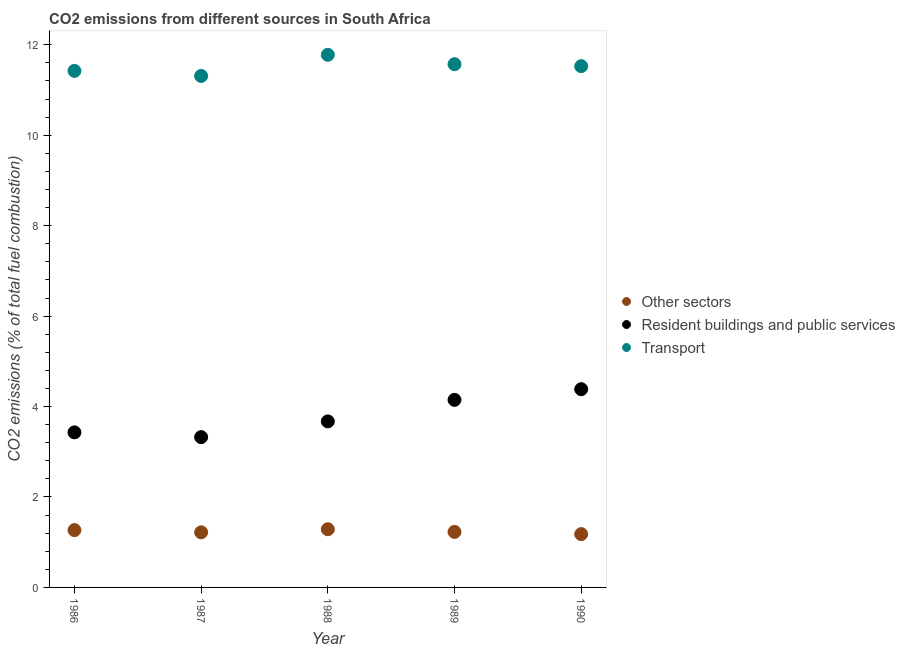What is the percentage of co2 emissions from transport in 1986?
Provide a short and direct response. 11.42. Across all years, what is the maximum percentage of co2 emissions from resident buildings and public services?
Provide a short and direct response. 4.38. Across all years, what is the minimum percentage of co2 emissions from resident buildings and public services?
Ensure brevity in your answer.  3.32. What is the total percentage of co2 emissions from transport in the graph?
Provide a short and direct response. 57.61. What is the difference between the percentage of co2 emissions from transport in 1986 and that in 1988?
Your response must be concise. -0.36. What is the difference between the percentage of co2 emissions from resident buildings and public services in 1988 and the percentage of co2 emissions from transport in 1990?
Keep it short and to the point. -7.86. What is the average percentage of co2 emissions from resident buildings and public services per year?
Provide a succinct answer. 3.79. In the year 1988, what is the difference between the percentage of co2 emissions from resident buildings and public services and percentage of co2 emissions from transport?
Your answer should be compact. -8.11. What is the ratio of the percentage of co2 emissions from transport in 1989 to that in 1990?
Keep it short and to the point. 1. Is the difference between the percentage of co2 emissions from transport in 1987 and 1988 greater than the difference between the percentage of co2 emissions from other sectors in 1987 and 1988?
Ensure brevity in your answer.  No. What is the difference between the highest and the second highest percentage of co2 emissions from transport?
Make the answer very short. 0.21. What is the difference between the highest and the lowest percentage of co2 emissions from transport?
Offer a terse response. 0.47. In how many years, is the percentage of co2 emissions from resident buildings and public services greater than the average percentage of co2 emissions from resident buildings and public services taken over all years?
Make the answer very short. 2. Is the sum of the percentage of co2 emissions from transport in 1988 and 1990 greater than the maximum percentage of co2 emissions from resident buildings and public services across all years?
Your answer should be compact. Yes. Does the percentage of co2 emissions from transport monotonically increase over the years?
Ensure brevity in your answer.  No. How many dotlines are there?
Provide a short and direct response. 3. Does the graph contain grids?
Offer a terse response. No. Where does the legend appear in the graph?
Your answer should be very brief. Center right. How are the legend labels stacked?
Offer a very short reply. Vertical. What is the title of the graph?
Offer a very short reply. CO2 emissions from different sources in South Africa. Does "Total employers" appear as one of the legend labels in the graph?
Your answer should be compact. No. What is the label or title of the Y-axis?
Offer a very short reply. CO2 emissions (% of total fuel combustion). What is the CO2 emissions (% of total fuel combustion) of Other sectors in 1986?
Offer a terse response. 1.27. What is the CO2 emissions (% of total fuel combustion) in Resident buildings and public services in 1986?
Keep it short and to the point. 3.43. What is the CO2 emissions (% of total fuel combustion) of Transport in 1986?
Your answer should be very brief. 11.42. What is the CO2 emissions (% of total fuel combustion) in Other sectors in 1987?
Your answer should be compact. 1.22. What is the CO2 emissions (% of total fuel combustion) in Resident buildings and public services in 1987?
Your answer should be compact. 3.32. What is the CO2 emissions (% of total fuel combustion) of Transport in 1987?
Provide a short and direct response. 11.31. What is the CO2 emissions (% of total fuel combustion) of Other sectors in 1988?
Give a very brief answer. 1.29. What is the CO2 emissions (% of total fuel combustion) of Resident buildings and public services in 1988?
Your response must be concise. 3.67. What is the CO2 emissions (% of total fuel combustion) of Transport in 1988?
Offer a terse response. 11.78. What is the CO2 emissions (% of total fuel combustion) in Other sectors in 1989?
Your answer should be compact. 1.23. What is the CO2 emissions (% of total fuel combustion) of Resident buildings and public services in 1989?
Your answer should be very brief. 4.15. What is the CO2 emissions (% of total fuel combustion) in Transport in 1989?
Offer a very short reply. 11.57. What is the CO2 emissions (% of total fuel combustion) of Other sectors in 1990?
Keep it short and to the point. 1.18. What is the CO2 emissions (% of total fuel combustion) in Resident buildings and public services in 1990?
Your answer should be compact. 4.38. What is the CO2 emissions (% of total fuel combustion) of Transport in 1990?
Keep it short and to the point. 11.53. Across all years, what is the maximum CO2 emissions (% of total fuel combustion) of Other sectors?
Your answer should be very brief. 1.29. Across all years, what is the maximum CO2 emissions (% of total fuel combustion) in Resident buildings and public services?
Provide a succinct answer. 4.38. Across all years, what is the maximum CO2 emissions (% of total fuel combustion) in Transport?
Your response must be concise. 11.78. Across all years, what is the minimum CO2 emissions (% of total fuel combustion) in Other sectors?
Ensure brevity in your answer.  1.18. Across all years, what is the minimum CO2 emissions (% of total fuel combustion) in Resident buildings and public services?
Offer a very short reply. 3.32. Across all years, what is the minimum CO2 emissions (% of total fuel combustion) of Transport?
Provide a succinct answer. 11.31. What is the total CO2 emissions (% of total fuel combustion) of Other sectors in the graph?
Make the answer very short. 6.18. What is the total CO2 emissions (% of total fuel combustion) in Resident buildings and public services in the graph?
Ensure brevity in your answer.  18.96. What is the total CO2 emissions (% of total fuel combustion) in Transport in the graph?
Provide a succinct answer. 57.61. What is the difference between the CO2 emissions (% of total fuel combustion) in Other sectors in 1986 and that in 1987?
Make the answer very short. 0.05. What is the difference between the CO2 emissions (% of total fuel combustion) in Resident buildings and public services in 1986 and that in 1987?
Your answer should be very brief. 0.11. What is the difference between the CO2 emissions (% of total fuel combustion) in Transport in 1986 and that in 1987?
Offer a very short reply. 0.11. What is the difference between the CO2 emissions (% of total fuel combustion) in Other sectors in 1986 and that in 1988?
Offer a very short reply. -0.02. What is the difference between the CO2 emissions (% of total fuel combustion) in Resident buildings and public services in 1986 and that in 1988?
Offer a very short reply. -0.24. What is the difference between the CO2 emissions (% of total fuel combustion) in Transport in 1986 and that in 1988?
Your response must be concise. -0.36. What is the difference between the CO2 emissions (% of total fuel combustion) of Other sectors in 1986 and that in 1989?
Provide a short and direct response. 0.04. What is the difference between the CO2 emissions (% of total fuel combustion) of Resident buildings and public services in 1986 and that in 1989?
Ensure brevity in your answer.  -0.72. What is the difference between the CO2 emissions (% of total fuel combustion) of Transport in 1986 and that in 1989?
Provide a short and direct response. -0.15. What is the difference between the CO2 emissions (% of total fuel combustion) of Other sectors in 1986 and that in 1990?
Your answer should be very brief. 0.09. What is the difference between the CO2 emissions (% of total fuel combustion) of Resident buildings and public services in 1986 and that in 1990?
Your answer should be compact. -0.95. What is the difference between the CO2 emissions (% of total fuel combustion) in Transport in 1986 and that in 1990?
Offer a terse response. -0.1. What is the difference between the CO2 emissions (% of total fuel combustion) of Other sectors in 1987 and that in 1988?
Keep it short and to the point. -0.07. What is the difference between the CO2 emissions (% of total fuel combustion) of Resident buildings and public services in 1987 and that in 1988?
Offer a terse response. -0.35. What is the difference between the CO2 emissions (% of total fuel combustion) of Transport in 1987 and that in 1988?
Provide a short and direct response. -0.47. What is the difference between the CO2 emissions (% of total fuel combustion) in Other sectors in 1987 and that in 1989?
Your response must be concise. -0.01. What is the difference between the CO2 emissions (% of total fuel combustion) in Resident buildings and public services in 1987 and that in 1989?
Your response must be concise. -0.82. What is the difference between the CO2 emissions (% of total fuel combustion) of Transport in 1987 and that in 1989?
Offer a very short reply. -0.26. What is the difference between the CO2 emissions (% of total fuel combustion) in Other sectors in 1987 and that in 1990?
Make the answer very short. 0.04. What is the difference between the CO2 emissions (% of total fuel combustion) of Resident buildings and public services in 1987 and that in 1990?
Keep it short and to the point. -1.06. What is the difference between the CO2 emissions (% of total fuel combustion) in Transport in 1987 and that in 1990?
Keep it short and to the point. -0.22. What is the difference between the CO2 emissions (% of total fuel combustion) of Other sectors in 1988 and that in 1989?
Give a very brief answer. 0.06. What is the difference between the CO2 emissions (% of total fuel combustion) in Resident buildings and public services in 1988 and that in 1989?
Offer a terse response. -0.48. What is the difference between the CO2 emissions (% of total fuel combustion) of Transport in 1988 and that in 1989?
Give a very brief answer. 0.21. What is the difference between the CO2 emissions (% of total fuel combustion) in Other sectors in 1988 and that in 1990?
Offer a very short reply. 0.11. What is the difference between the CO2 emissions (% of total fuel combustion) of Resident buildings and public services in 1988 and that in 1990?
Offer a terse response. -0.71. What is the difference between the CO2 emissions (% of total fuel combustion) in Transport in 1988 and that in 1990?
Your answer should be very brief. 0.25. What is the difference between the CO2 emissions (% of total fuel combustion) in Other sectors in 1989 and that in 1990?
Provide a succinct answer. 0.05. What is the difference between the CO2 emissions (% of total fuel combustion) of Resident buildings and public services in 1989 and that in 1990?
Offer a terse response. -0.24. What is the difference between the CO2 emissions (% of total fuel combustion) of Transport in 1989 and that in 1990?
Your answer should be very brief. 0.04. What is the difference between the CO2 emissions (% of total fuel combustion) in Other sectors in 1986 and the CO2 emissions (% of total fuel combustion) in Resident buildings and public services in 1987?
Your answer should be very brief. -2.06. What is the difference between the CO2 emissions (% of total fuel combustion) in Other sectors in 1986 and the CO2 emissions (% of total fuel combustion) in Transport in 1987?
Offer a terse response. -10.04. What is the difference between the CO2 emissions (% of total fuel combustion) in Resident buildings and public services in 1986 and the CO2 emissions (% of total fuel combustion) in Transport in 1987?
Ensure brevity in your answer.  -7.88. What is the difference between the CO2 emissions (% of total fuel combustion) in Other sectors in 1986 and the CO2 emissions (% of total fuel combustion) in Resident buildings and public services in 1988?
Give a very brief answer. -2.4. What is the difference between the CO2 emissions (% of total fuel combustion) in Other sectors in 1986 and the CO2 emissions (% of total fuel combustion) in Transport in 1988?
Ensure brevity in your answer.  -10.51. What is the difference between the CO2 emissions (% of total fuel combustion) in Resident buildings and public services in 1986 and the CO2 emissions (% of total fuel combustion) in Transport in 1988?
Your answer should be very brief. -8.35. What is the difference between the CO2 emissions (% of total fuel combustion) of Other sectors in 1986 and the CO2 emissions (% of total fuel combustion) of Resident buildings and public services in 1989?
Ensure brevity in your answer.  -2.88. What is the difference between the CO2 emissions (% of total fuel combustion) of Other sectors in 1986 and the CO2 emissions (% of total fuel combustion) of Transport in 1989?
Your answer should be very brief. -10.3. What is the difference between the CO2 emissions (% of total fuel combustion) in Resident buildings and public services in 1986 and the CO2 emissions (% of total fuel combustion) in Transport in 1989?
Provide a short and direct response. -8.14. What is the difference between the CO2 emissions (% of total fuel combustion) in Other sectors in 1986 and the CO2 emissions (% of total fuel combustion) in Resident buildings and public services in 1990?
Your answer should be compact. -3.12. What is the difference between the CO2 emissions (% of total fuel combustion) in Other sectors in 1986 and the CO2 emissions (% of total fuel combustion) in Transport in 1990?
Provide a succinct answer. -10.26. What is the difference between the CO2 emissions (% of total fuel combustion) in Resident buildings and public services in 1986 and the CO2 emissions (% of total fuel combustion) in Transport in 1990?
Offer a very short reply. -8.1. What is the difference between the CO2 emissions (% of total fuel combustion) of Other sectors in 1987 and the CO2 emissions (% of total fuel combustion) of Resident buildings and public services in 1988?
Provide a succinct answer. -2.45. What is the difference between the CO2 emissions (% of total fuel combustion) of Other sectors in 1987 and the CO2 emissions (% of total fuel combustion) of Transport in 1988?
Make the answer very short. -10.56. What is the difference between the CO2 emissions (% of total fuel combustion) of Resident buildings and public services in 1987 and the CO2 emissions (% of total fuel combustion) of Transport in 1988?
Provide a short and direct response. -8.46. What is the difference between the CO2 emissions (% of total fuel combustion) in Other sectors in 1987 and the CO2 emissions (% of total fuel combustion) in Resident buildings and public services in 1989?
Provide a succinct answer. -2.93. What is the difference between the CO2 emissions (% of total fuel combustion) in Other sectors in 1987 and the CO2 emissions (% of total fuel combustion) in Transport in 1989?
Offer a terse response. -10.35. What is the difference between the CO2 emissions (% of total fuel combustion) of Resident buildings and public services in 1987 and the CO2 emissions (% of total fuel combustion) of Transport in 1989?
Provide a succinct answer. -8.25. What is the difference between the CO2 emissions (% of total fuel combustion) of Other sectors in 1987 and the CO2 emissions (% of total fuel combustion) of Resident buildings and public services in 1990?
Your response must be concise. -3.17. What is the difference between the CO2 emissions (% of total fuel combustion) in Other sectors in 1987 and the CO2 emissions (% of total fuel combustion) in Transport in 1990?
Your response must be concise. -10.31. What is the difference between the CO2 emissions (% of total fuel combustion) in Resident buildings and public services in 1987 and the CO2 emissions (% of total fuel combustion) in Transport in 1990?
Keep it short and to the point. -8.2. What is the difference between the CO2 emissions (% of total fuel combustion) of Other sectors in 1988 and the CO2 emissions (% of total fuel combustion) of Resident buildings and public services in 1989?
Your answer should be very brief. -2.86. What is the difference between the CO2 emissions (% of total fuel combustion) of Other sectors in 1988 and the CO2 emissions (% of total fuel combustion) of Transport in 1989?
Your answer should be compact. -10.28. What is the difference between the CO2 emissions (% of total fuel combustion) of Resident buildings and public services in 1988 and the CO2 emissions (% of total fuel combustion) of Transport in 1989?
Your answer should be very brief. -7.9. What is the difference between the CO2 emissions (% of total fuel combustion) of Other sectors in 1988 and the CO2 emissions (% of total fuel combustion) of Resident buildings and public services in 1990?
Your answer should be very brief. -3.1. What is the difference between the CO2 emissions (% of total fuel combustion) in Other sectors in 1988 and the CO2 emissions (% of total fuel combustion) in Transport in 1990?
Provide a succinct answer. -10.24. What is the difference between the CO2 emissions (% of total fuel combustion) in Resident buildings and public services in 1988 and the CO2 emissions (% of total fuel combustion) in Transport in 1990?
Ensure brevity in your answer.  -7.86. What is the difference between the CO2 emissions (% of total fuel combustion) of Other sectors in 1989 and the CO2 emissions (% of total fuel combustion) of Resident buildings and public services in 1990?
Make the answer very short. -3.16. What is the difference between the CO2 emissions (% of total fuel combustion) in Other sectors in 1989 and the CO2 emissions (% of total fuel combustion) in Transport in 1990?
Ensure brevity in your answer.  -10.3. What is the difference between the CO2 emissions (% of total fuel combustion) in Resident buildings and public services in 1989 and the CO2 emissions (% of total fuel combustion) in Transport in 1990?
Keep it short and to the point. -7.38. What is the average CO2 emissions (% of total fuel combustion) of Other sectors per year?
Give a very brief answer. 1.24. What is the average CO2 emissions (% of total fuel combustion) in Resident buildings and public services per year?
Make the answer very short. 3.79. What is the average CO2 emissions (% of total fuel combustion) in Transport per year?
Give a very brief answer. 11.52. In the year 1986, what is the difference between the CO2 emissions (% of total fuel combustion) in Other sectors and CO2 emissions (% of total fuel combustion) in Resident buildings and public services?
Provide a short and direct response. -2.16. In the year 1986, what is the difference between the CO2 emissions (% of total fuel combustion) of Other sectors and CO2 emissions (% of total fuel combustion) of Transport?
Offer a terse response. -10.16. In the year 1986, what is the difference between the CO2 emissions (% of total fuel combustion) in Resident buildings and public services and CO2 emissions (% of total fuel combustion) in Transport?
Provide a succinct answer. -7.99. In the year 1987, what is the difference between the CO2 emissions (% of total fuel combustion) of Other sectors and CO2 emissions (% of total fuel combustion) of Resident buildings and public services?
Your answer should be compact. -2.1. In the year 1987, what is the difference between the CO2 emissions (% of total fuel combustion) of Other sectors and CO2 emissions (% of total fuel combustion) of Transport?
Your response must be concise. -10.09. In the year 1987, what is the difference between the CO2 emissions (% of total fuel combustion) in Resident buildings and public services and CO2 emissions (% of total fuel combustion) in Transport?
Your answer should be very brief. -7.99. In the year 1988, what is the difference between the CO2 emissions (% of total fuel combustion) of Other sectors and CO2 emissions (% of total fuel combustion) of Resident buildings and public services?
Offer a terse response. -2.39. In the year 1988, what is the difference between the CO2 emissions (% of total fuel combustion) of Other sectors and CO2 emissions (% of total fuel combustion) of Transport?
Offer a terse response. -10.49. In the year 1988, what is the difference between the CO2 emissions (% of total fuel combustion) of Resident buildings and public services and CO2 emissions (% of total fuel combustion) of Transport?
Offer a very short reply. -8.11. In the year 1989, what is the difference between the CO2 emissions (% of total fuel combustion) in Other sectors and CO2 emissions (% of total fuel combustion) in Resident buildings and public services?
Provide a short and direct response. -2.92. In the year 1989, what is the difference between the CO2 emissions (% of total fuel combustion) of Other sectors and CO2 emissions (% of total fuel combustion) of Transport?
Provide a short and direct response. -10.34. In the year 1989, what is the difference between the CO2 emissions (% of total fuel combustion) in Resident buildings and public services and CO2 emissions (% of total fuel combustion) in Transport?
Offer a very short reply. -7.42. In the year 1990, what is the difference between the CO2 emissions (% of total fuel combustion) of Other sectors and CO2 emissions (% of total fuel combustion) of Resident buildings and public services?
Your answer should be very brief. -3.21. In the year 1990, what is the difference between the CO2 emissions (% of total fuel combustion) of Other sectors and CO2 emissions (% of total fuel combustion) of Transport?
Ensure brevity in your answer.  -10.35. In the year 1990, what is the difference between the CO2 emissions (% of total fuel combustion) in Resident buildings and public services and CO2 emissions (% of total fuel combustion) in Transport?
Provide a short and direct response. -7.14. What is the ratio of the CO2 emissions (% of total fuel combustion) of Other sectors in 1986 to that in 1987?
Offer a terse response. 1.04. What is the ratio of the CO2 emissions (% of total fuel combustion) in Resident buildings and public services in 1986 to that in 1987?
Make the answer very short. 1.03. What is the ratio of the CO2 emissions (% of total fuel combustion) of Transport in 1986 to that in 1987?
Provide a short and direct response. 1.01. What is the ratio of the CO2 emissions (% of total fuel combustion) of Other sectors in 1986 to that in 1988?
Your answer should be compact. 0.99. What is the ratio of the CO2 emissions (% of total fuel combustion) of Resident buildings and public services in 1986 to that in 1988?
Keep it short and to the point. 0.93. What is the ratio of the CO2 emissions (% of total fuel combustion) in Transport in 1986 to that in 1988?
Your answer should be compact. 0.97. What is the ratio of the CO2 emissions (% of total fuel combustion) in Other sectors in 1986 to that in 1989?
Keep it short and to the point. 1.03. What is the ratio of the CO2 emissions (% of total fuel combustion) of Resident buildings and public services in 1986 to that in 1989?
Provide a short and direct response. 0.83. What is the ratio of the CO2 emissions (% of total fuel combustion) in Transport in 1986 to that in 1989?
Keep it short and to the point. 0.99. What is the ratio of the CO2 emissions (% of total fuel combustion) in Other sectors in 1986 to that in 1990?
Provide a short and direct response. 1.07. What is the ratio of the CO2 emissions (% of total fuel combustion) in Resident buildings and public services in 1986 to that in 1990?
Your response must be concise. 0.78. What is the ratio of the CO2 emissions (% of total fuel combustion) in Transport in 1986 to that in 1990?
Offer a terse response. 0.99. What is the ratio of the CO2 emissions (% of total fuel combustion) in Other sectors in 1987 to that in 1988?
Make the answer very short. 0.95. What is the ratio of the CO2 emissions (% of total fuel combustion) in Resident buildings and public services in 1987 to that in 1988?
Offer a terse response. 0.91. What is the ratio of the CO2 emissions (% of total fuel combustion) of Transport in 1987 to that in 1988?
Ensure brevity in your answer.  0.96. What is the ratio of the CO2 emissions (% of total fuel combustion) of Resident buildings and public services in 1987 to that in 1989?
Offer a terse response. 0.8. What is the ratio of the CO2 emissions (% of total fuel combustion) of Transport in 1987 to that in 1989?
Provide a short and direct response. 0.98. What is the ratio of the CO2 emissions (% of total fuel combustion) of Other sectors in 1987 to that in 1990?
Your answer should be very brief. 1.03. What is the ratio of the CO2 emissions (% of total fuel combustion) of Resident buildings and public services in 1987 to that in 1990?
Your answer should be compact. 0.76. What is the ratio of the CO2 emissions (% of total fuel combustion) of Transport in 1987 to that in 1990?
Offer a terse response. 0.98. What is the ratio of the CO2 emissions (% of total fuel combustion) in Other sectors in 1988 to that in 1989?
Offer a terse response. 1.05. What is the ratio of the CO2 emissions (% of total fuel combustion) in Resident buildings and public services in 1988 to that in 1989?
Provide a short and direct response. 0.89. What is the ratio of the CO2 emissions (% of total fuel combustion) of Other sectors in 1988 to that in 1990?
Ensure brevity in your answer.  1.09. What is the ratio of the CO2 emissions (% of total fuel combustion) of Resident buildings and public services in 1988 to that in 1990?
Your answer should be very brief. 0.84. What is the ratio of the CO2 emissions (% of total fuel combustion) in Transport in 1988 to that in 1990?
Offer a terse response. 1.02. What is the ratio of the CO2 emissions (% of total fuel combustion) in Other sectors in 1989 to that in 1990?
Provide a succinct answer. 1.04. What is the ratio of the CO2 emissions (% of total fuel combustion) in Resident buildings and public services in 1989 to that in 1990?
Ensure brevity in your answer.  0.95. What is the ratio of the CO2 emissions (% of total fuel combustion) of Transport in 1989 to that in 1990?
Provide a short and direct response. 1. What is the difference between the highest and the second highest CO2 emissions (% of total fuel combustion) in Other sectors?
Your response must be concise. 0.02. What is the difference between the highest and the second highest CO2 emissions (% of total fuel combustion) of Resident buildings and public services?
Provide a short and direct response. 0.24. What is the difference between the highest and the second highest CO2 emissions (% of total fuel combustion) of Transport?
Your response must be concise. 0.21. What is the difference between the highest and the lowest CO2 emissions (% of total fuel combustion) in Other sectors?
Ensure brevity in your answer.  0.11. What is the difference between the highest and the lowest CO2 emissions (% of total fuel combustion) of Resident buildings and public services?
Give a very brief answer. 1.06. What is the difference between the highest and the lowest CO2 emissions (% of total fuel combustion) of Transport?
Your answer should be very brief. 0.47. 